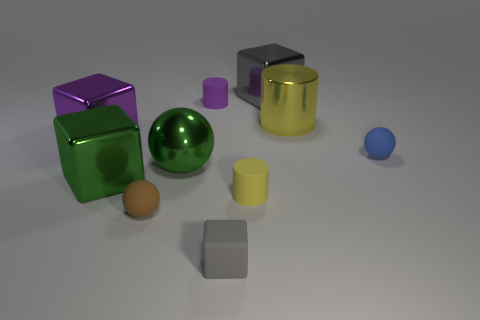Subtract all big gray blocks. How many blocks are left? 3 Subtract all purple blocks. How many blocks are left? 3 Subtract all cyan cubes. Subtract all blue balls. How many cubes are left? 4 Subtract all blocks. How many objects are left? 6 Subtract 1 blue balls. How many objects are left? 9 Subtract all metal objects. Subtract all large yellow metallic objects. How many objects are left? 4 Add 4 gray blocks. How many gray blocks are left? 6 Add 10 red metallic cylinders. How many red metallic cylinders exist? 10 